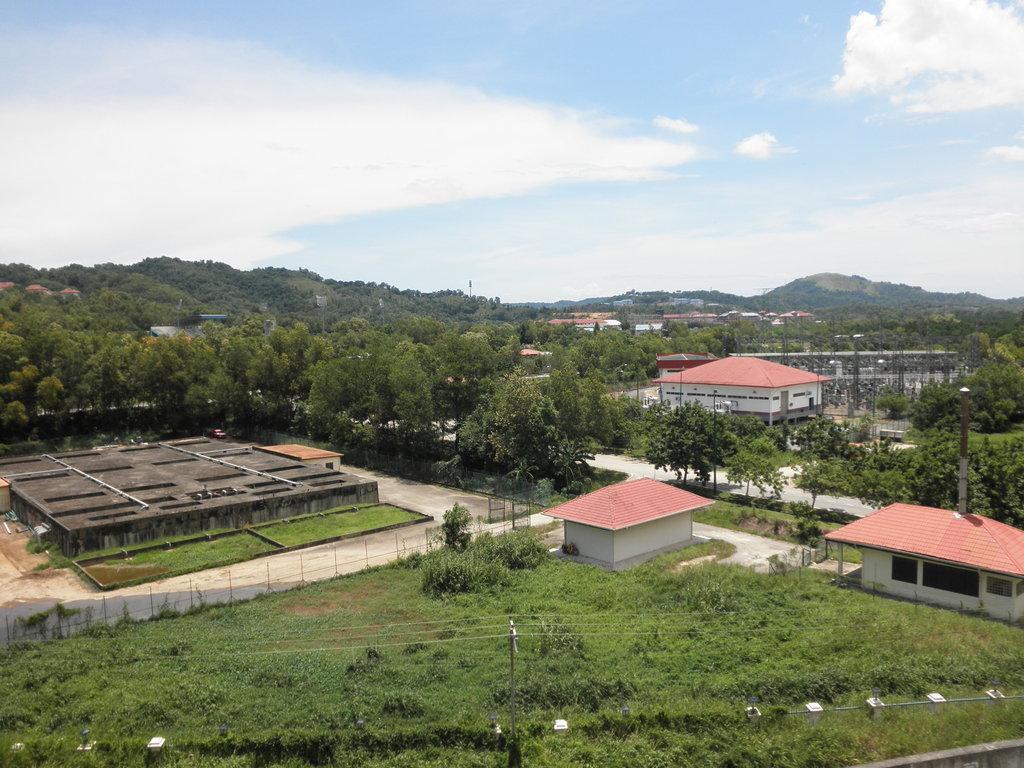Describe this image in one or two sentences. In this image in the center there is grass on the ground and there are buildings. In the background there are trees and the sky is cloudy. 